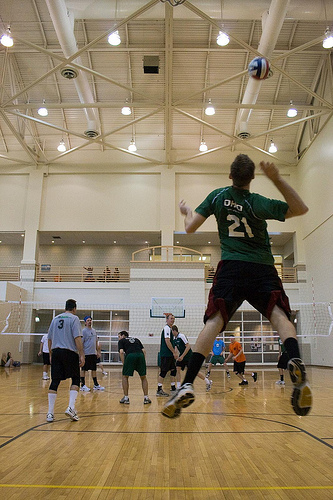<image>
Is there a man behind the ball? Yes. From this viewpoint, the man is positioned behind the ball, with the ball partially or fully occluding the man. 